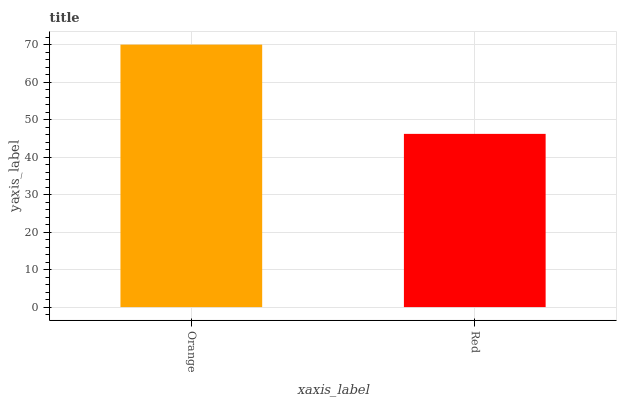Is Red the minimum?
Answer yes or no. Yes. Is Orange the maximum?
Answer yes or no. Yes. Is Red the maximum?
Answer yes or no. No. Is Orange greater than Red?
Answer yes or no. Yes. Is Red less than Orange?
Answer yes or no. Yes. Is Red greater than Orange?
Answer yes or no. No. Is Orange less than Red?
Answer yes or no. No. Is Orange the high median?
Answer yes or no. Yes. Is Red the low median?
Answer yes or no. Yes. Is Red the high median?
Answer yes or no. No. Is Orange the low median?
Answer yes or no. No. 